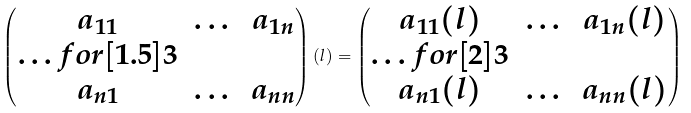<formula> <loc_0><loc_0><loc_500><loc_500>\begin{pmatrix} a _ { 1 1 } & \dots & a _ { 1 n } \\ \hdots f o r [ 1 . 5 ] { 3 } \\ a _ { n 1 } & \dots & a _ { n n } \end{pmatrix} ( l ) = \begin{pmatrix} a _ { 1 1 } ( l ) & \dots & a _ { 1 n } ( l ) \\ \hdots f o r [ 2 ] { 3 } \\ a _ { n 1 } ( l ) & \dots & a _ { n n } ( l ) \end{pmatrix}</formula> 